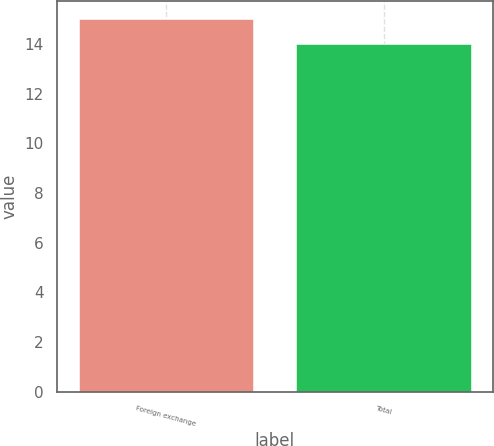Convert chart to OTSL. <chart><loc_0><loc_0><loc_500><loc_500><bar_chart><fcel>Foreign exchange<fcel>Total<nl><fcel>15<fcel>14<nl></chart> 